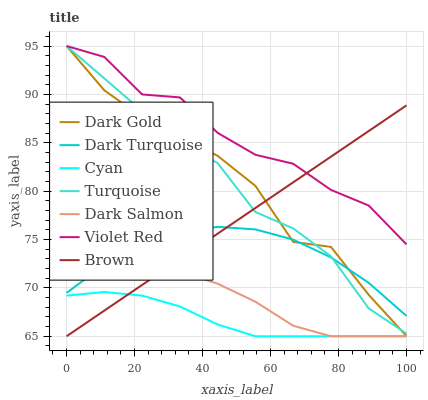Does Cyan have the minimum area under the curve?
Answer yes or no. Yes. Does Violet Red have the maximum area under the curve?
Answer yes or no. Yes. Does Dark Gold have the minimum area under the curve?
Answer yes or no. No. Does Dark Gold have the maximum area under the curve?
Answer yes or no. No. Is Brown the smoothest?
Answer yes or no. Yes. Is Violet Red the roughest?
Answer yes or no. Yes. Is Dark Gold the smoothest?
Answer yes or no. No. Is Dark Gold the roughest?
Answer yes or no. No. Does Brown have the lowest value?
Answer yes or no. Yes. Does Dark Gold have the lowest value?
Answer yes or no. No. Does Turquoise have the highest value?
Answer yes or no. Yes. Does Dark Turquoise have the highest value?
Answer yes or no. No. Is Cyan less than Turquoise?
Answer yes or no. Yes. Is Dark Gold greater than Dark Salmon?
Answer yes or no. Yes. Does Dark Gold intersect Dark Turquoise?
Answer yes or no. Yes. Is Dark Gold less than Dark Turquoise?
Answer yes or no. No. Is Dark Gold greater than Dark Turquoise?
Answer yes or no. No. Does Cyan intersect Turquoise?
Answer yes or no. No. 